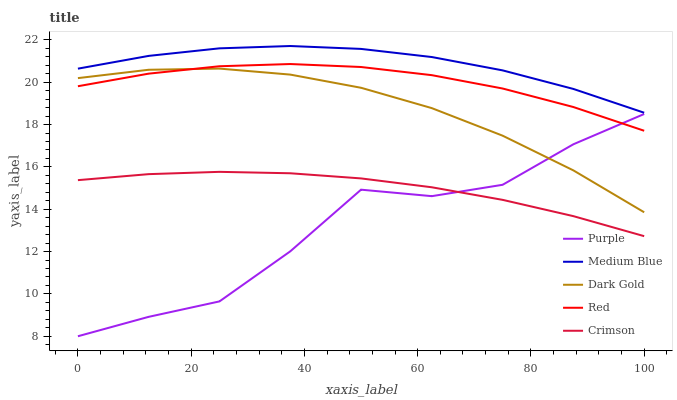Does Purple have the minimum area under the curve?
Answer yes or no. Yes. Does Medium Blue have the maximum area under the curve?
Answer yes or no. Yes. Does Crimson have the minimum area under the curve?
Answer yes or no. No. Does Crimson have the maximum area under the curve?
Answer yes or no. No. Is Crimson the smoothest?
Answer yes or no. Yes. Is Purple the roughest?
Answer yes or no. Yes. Is Medium Blue the smoothest?
Answer yes or no. No. Is Medium Blue the roughest?
Answer yes or no. No. Does Crimson have the lowest value?
Answer yes or no. No. Does Medium Blue have the highest value?
Answer yes or no. Yes. Does Crimson have the highest value?
Answer yes or no. No. Is Red less than Medium Blue?
Answer yes or no. Yes. Is Dark Gold greater than Crimson?
Answer yes or no. Yes. Does Dark Gold intersect Purple?
Answer yes or no. Yes. Is Dark Gold less than Purple?
Answer yes or no. No. Is Dark Gold greater than Purple?
Answer yes or no. No. Does Red intersect Medium Blue?
Answer yes or no. No. 